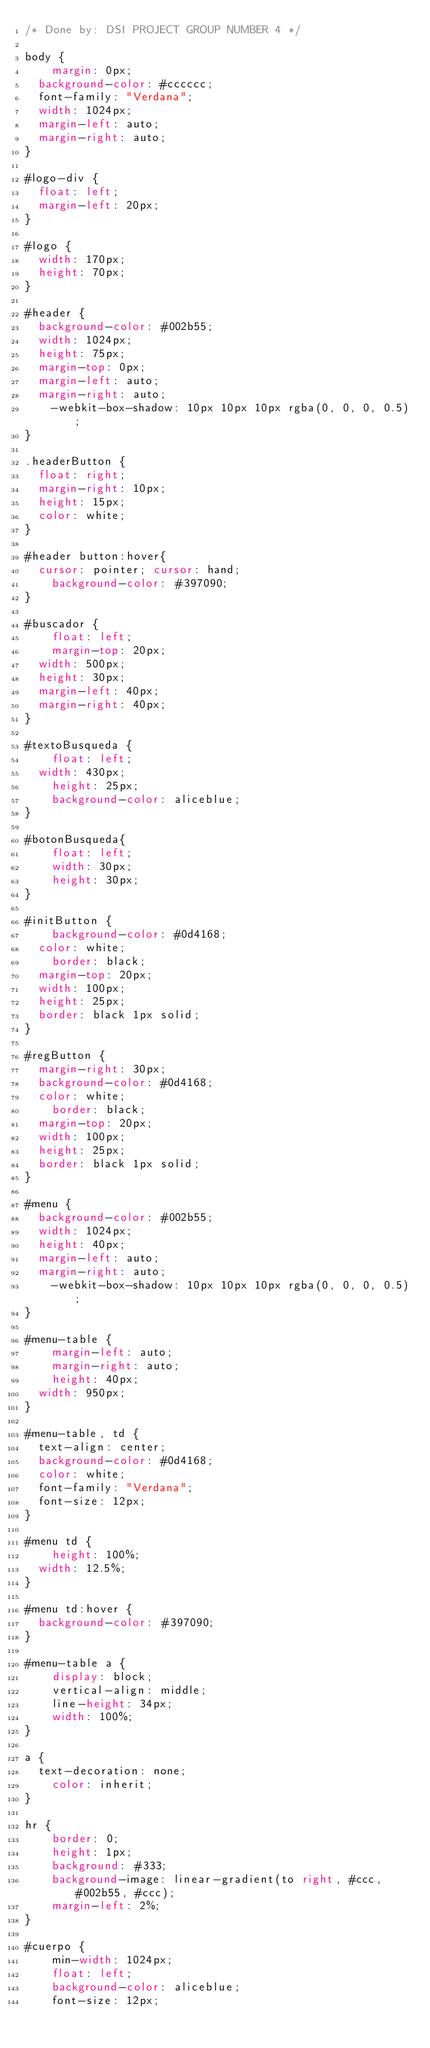Convert code to text. <code><loc_0><loc_0><loc_500><loc_500><_CSS_>/* Done by: DSI PROJECT GROUP NUMBER 4 */

body {
    margin: 0px;
	background-color: #cccccc;
	font-family: "Verdana";
	width: 1024px;
	margin-left: auto;
	margin-right: auto;
}

#logo-div {
	float: left;
	margin-left: 20px;
}

#logo {
	width: 170px;
	height: 70px;
}

#header {
	background-color: #002b55;
	width: 1024px;
	height: 75px;
	margin-top: 0px;
	margin-left: auto;
	margin-right: auto;
    -webkit-box-shadow: 10px 10px 10px rgba(0, 0, 0, 0.5);
}

.headerButton {
	float: right;
	margin-right: 10px;
	height: 15px;
	color: white;
}

#header button:hover{
	cursor: pointer; cursor: hand;
    background-color: #397090;
}

#buscador {
    float: left;
    margin-top: 20px;
	width: 500px;
	height: 30px;
	margin-left: 40px;
	margin-right: 40px;
}

#textoBusqueda {
    float: left;
	width: 430px;
    height: 25px;
    background-color: aliceblue;
}

#botonBusqueda{
    float: left;
    width: 30px;
    height: 30px;
}

#initButton {
    background-color: #0d4168;
	color: white;
    border: black;
	margin-top: 20px;
	width: 100px;
	height: 25px;
	border: black 1px solid;
}

#regButton {
	margin-right: 30px;
	background-color: #0d4168;
	color: white;
    border: black;
	margin-top: 20px;
	width: 100px;
	height: 25px;
	border: black 1px solid;
}

#menu {
	background-color: #002b55;
	width: 1024px;
	height: 40px;
	margin-left: auto;
	margin-right: auto;
    -webkit-box-shadow: 10px 10px 10px rgba(0, 0, 0, 0.5);
}

#menu-table {
    margin-left: auto;
    margin-right: auto;
    height: 40px;
	width: 950px;
}

#menu-table, td {
	text-align: center;
	background-color: #0d4168;
	color: white;
	font-family: "Verdana";
	font-size: 12px;
}

#menu td {
    height: 100%;
	width: 12.5%;
}

#menu td:hover {
	background-color: #397090;
}

#menu-table a {
    display: block;
    vertical-align: middle;
    line-height: 34px;
    width: 100%;
}

a {
	text-decoration: none;
    color: inherit;
}

hr {
    border: 0;
    height: 1px;
    background: #333;
    background-image: linear-gradient(to right, #ccc, #002b55, #ccc);
    margin-left: 2%;
}

#cuerpo {
    min-width: 1024px;
    float: left;
    background-color: aliceblue;
    font-size: 12px;</code> 